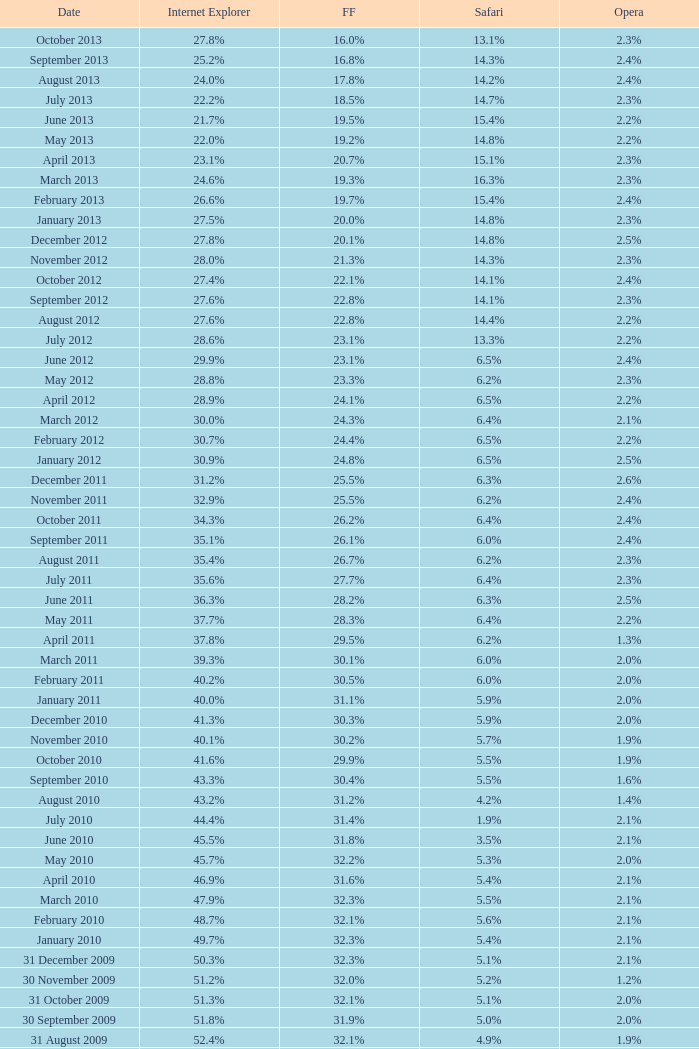What is the firefox value with a 22.0% internet explorer? 19.2%. Could you parse the entire table? {'header': ['Date', 'Internet Explorer', 'FF', 'Safari', 'Opera'], 'rows': [['October 2013', '27.8%', '16.0%', '13.1%', '2.3%'], ['September 2013', '25.2%', '16.8%', '14.3%', '2.4%'], ['August 2013', '24.0%', '17.8%', '14.2%', '2.4%'], ['July 2013', '22.2%', '18.5%', '14.7%', '2.3%'], ['June 2013', '21.7%', '19.5%', '15.4%', '2.2%'], ['May 2013', '22.0%', '19.2%', '14.8%', '2.2%'], ['April 2013', '23.1%', '20.7%', '15.1%', '2.3%'], ['March 2013', '24.6%', '19.3%', '16.3%', '2.3%'], ['February 2013', '26.6%', '19.7%', '15.4%', '2.4%'], ['January 2013', '27.5%', '20.0%', '14.8%', '2.3%'], ['December 2012', '27.8%', '20.1%', '14.8%', '2.5%'], ['November 2012', '28.0%', '21.3%', '14.3%', '2.3%'], ['October 2012', '27.4%', '22.1%', '14.1%', '2.4%'], ['September 2012', '27.6%', '22.8%', '14.1%', '2.3%'], ['August 2012', '27.6%', '22.8%', '14.4%', '2.2%'], ['July 2012', '28.6%', '23.1%', '13.3%', '2.2%'], ['June 2012', '29.9%', '23.1%', '6.5%', '2.4%'], ['May 2012', '28.8%', '23.3%', '6.2%', '2.3%'], ['April 2012', '28.9%', '24.1%', '6.5%', '2.2%'], ['March 2012', '30.0%', '24.3%', '6.4%', '2.1%'], ['February 2012', '30.7%', '24.4%', '6.5%', '2.2%'], ['January 2012', '30.9%', '24.8%', '6.5%', '2.5%'], ['December 2011', '31.2%', '25.5%', '6.3%', '2.6%'], ['November 2011', '32.9%', '25.5%', '6.2%', '2.4%'], ['October 2011', '34.3%', '26.2%', '6.4%', '2.4%'], ['September 2011', '35.1%', '26.1%', '6.0%', '2.4%'], ['August 2011', '35.4%', '26.7%', '6.2%', '2.3%'], ['July 2011', '35.6%', '27.7%', '6.4%', '2.3%'], ['June 2011', '36.3%', '28.2%', '6.3%', '2.5%'], ['May 2011', '37.7%', '28.3%', '6.4%', '2.2%'], ['April 2011', '37.8%', '29.5%', '6.2%', '1.3%'], ['March 2011', '39.3%', '30.1%', '6.0%', '2.0%'], ['February 2011', '40.2%', '30.5%', '6.0%', '2.0%'], ['January 2011', '40.0%', '31.1%', '5.9%', '2.0%'], ['December 2010', '41.3%', '30.3%', '5.9%', '2.0%'], ['November 2010', '40.1%', '30.2%', '5.7%', '1.9%'], ['October 2010', '41.6%', '29.9%', '5.5%', '1.9%'], ['September 2010', '43.3%', '30.4%', '5.5%', '1.6%'], ['August 2010', '43.2%', '31.2%', '4.2%', '1.4%'], ['July 2010', '44.4%', '31.4%', '1.9%', '2.1%'], ['June 2010', '45.5%', '31.8%', '3.5%', '2.1%'], ['May 2010', '45.7%', '32.2%', '5.3%', '2.0%'], ['April 2010', '46.9%', '31.6%', '5.4%', '2.1%'], ['March 2010', '47.9%', '32.3%', '5.5%', '2.1%'], ['February 2010', '48.7%', '32.1%', '5.6%', '2.1%'], ['January 2010', '49.7%', '32.3%', '5.4%', '2.1%'], ['31 December 2009', '50.3%', '32.3%', '5.1%', '2.1%'], ['30 November 2009', '51.2%', '32.0%', '5.2%', '1.2%'], ['31 October 2009', '51.3%', '32.1%', '5.1%', '2.0%'], ['30 September 2009', '51.8%', '31.9%', '5.0%', '2.0%'], ['31 August 2009', '52.4%', '32.1%', '4.9%', '1.9%'], ['31 July 2009', '53.1%', '31.7%', '4.6%', '1.8%'], ['30 June 2009', '57.1%', '31.6%', '3.2%', '2.0%'], ['31 May 2009', '57.5%', '31.4%', '3.1%', '2.0%'], ['30 April 2009', '57.6%', '31.6%', '2.9%', '2.0%'], ['31 March 2009', '57.8%', '31.5%', '2.8%', '2.0%'], ['28 February 2009', '58.1%', '31.3%', '2.7%', '2.0%'], ['31 January 2009', '58.4%', '31.1%', '2.7%', '2.0%'], ['31 December 2008', '58.6%', '31.1%', '2.9%', '2.1%'], ['30 November 2008', '59.0%', '30.8%', '3.0%', '2.0%'], ['31 October 2008', '59.4%', '30.6%', '3.0%', '2.0%'], ['30 September 2008', '57.3%', '32.5%', '2.7%', '2.0%'], ['31 August 2008', '58.7%', '31.4%', '2.4%', '2.1%'], ['31 July 2008', '60.9%', '29.7%', '2.4%', '2.0%'], ['30 June 2008', '61.7%', '29.1%', '2.5%', '2.0%'], ['31 May 2008', '61.9%', '28.9%', '2.7%', '2.0%'], ['30 April 2008', '62.0%', '28.8%', '2.8%', '2.0%'], ['31 March 2008', '62.0%', '28.8%', '2.8%', '2.0%'], ['29 February 2008', '62.0%', '28.7%', '2.8%', '2.0%'], ['31 January 2008', '62.2%', '28.7%', '2.7%', '2.0%'], ['1 December 2007', '62.8%', '28.0%', '2.6%', '2.0%'], ['10 November 2007', '63.0%', '27.8%', '2.5%', '2.0%'], ['30 October 2007', '65.5%', '26.3%', '2.3%', '1.8%'], ['20 September 2007', '66.6%', '25.6%', '2.1%', '1.8%'], ['30 August 2007', '66.7%', '25.5%', '2.1%', '1.8%'], ['30 July 2007', '66.9%', '25.1%', '2.2%', '1.8%'], ['30 June 2007', '66.9%', '25.1%', '2.3%', '1.8%'], ['30 May 2007', '67.1%', '24.8%', '2.4%', '1.8%'], ['Date', 'Internet Explorer', 'Firefox', 'Safari', 'Opera']]} 